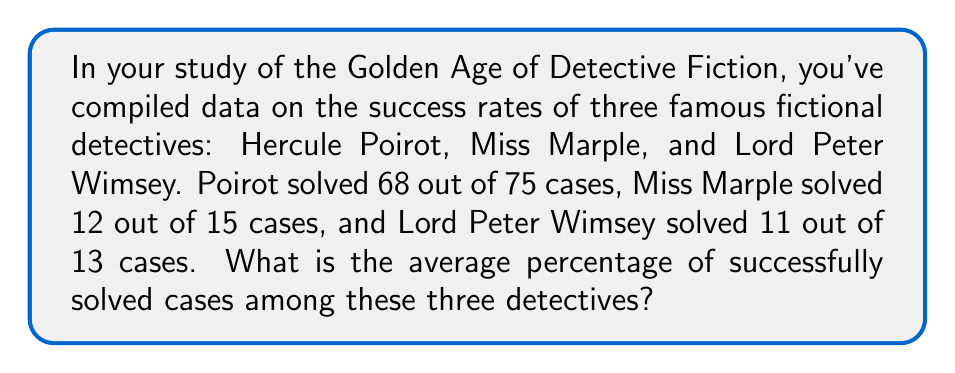Teach me how to tackle this problem. To solve this problem, we need to follow these steps:

1. Calculate the success rate for each detective as a percentage:

   Hercule Poirot: 
   $\frac{68}{75} \times 100\% = 90.67\%$

   Miss Marple:
   $\frac{12}{15} \times 100\% = 80\%$

   Lord Peter Wimsey:
   $\frac{11}{13} \times 100\% = 84.62\%$

2. Calculate the average of these percentages:

   $\text{Average} = \frac{\text{Sum of percentages}}{\text{Number of detectives}}$

   $\text{Average} = \frac{90.67\% + 80\% + 84.62\%}{3}$

   $\text{Average} = \frac{255.29\%}{3} = 85.10\%$

Therefore, the average percentage of successfully solved cases among these three detectives is 85.10%.
Answer: 85.10% 